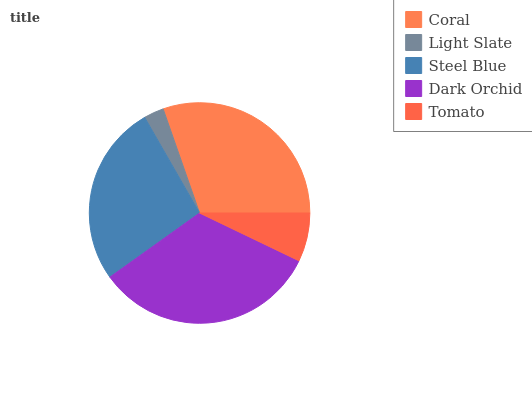Is Light Slate the minimum?
Answer yes or no. Yes. Is Dark Orchid the maximum?
Answer yes or no. Yes. Is Steel Blue the minimum?
Answer yes or no. No. Is Steel Blue the maximum?
Answer yes or no. No. Is Steel Blue greater than Light Slate?
Answer yes or no. Yes. Is Light Slate less than Steel Blue?
Answer yes or no. Yes. Is Light Slate greater than Steel Blue?
Answer yes or no. No. Is Steel Blue less than Light Slate?
Answer yes or no. No. Is Steel Blue the high median?
Answer yes or no. Yes. Is Steel Blue the low median?
Answer yes or no. Yes. Is Coral the high median?
Answer yes or no. No. Is Dark Orchid the low median?
Answer yes or no. No. 